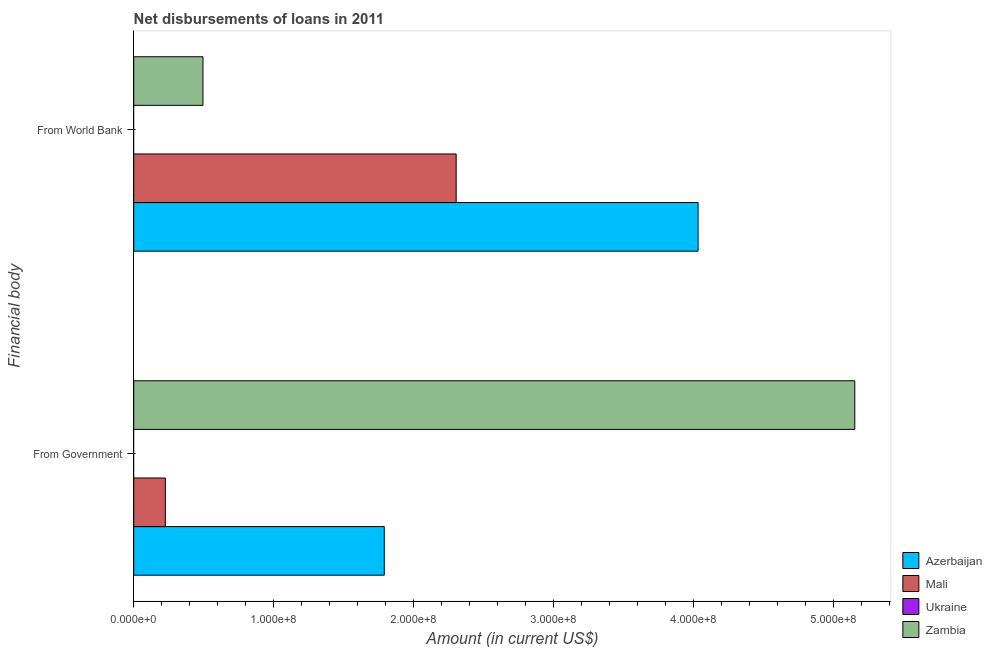How many groups of bars are there?
Your answer should be compact. 2. What is the label of the 1st group of bars from the top?
Your answer should be very brief. From World Bank. What is the net disbursements of loan from government in Zambia?
Ensure brevity in your answer.  5.15e+08. Across all countries, what is the maximum net disbursements of loan from government?
Your response must be concise. 5.15e+08. In which country was the net disbursements of loan from government maximum?
Offer a very short reply. Zambia. What is the total net disbursements of loan from world bank in the graph?
Keep it short and to the point. 6.83e+08. What is the difference between the net disbursements of loan from government in Zambia and that in Azerbaijan?
Offer a terse response. 3.36e+08. What is the difference between the net disbursements of loan from government in Ukraine and the net disbursements of loan from world bank in Azerbaijan?
Your answer should be compact. -4.03e+08. What is the average net disbursements of loan from world bank per country?
Make the answer very short. 1.71e+08. What is the difference between the net disbursements of loan from world bank and net disbursements of loan from government in Zambia?
Offer a very short reply. -4.66e+08. In how many countries, is the net disbursements of loan from world bank greater than 20000000 US$?
Provide a short and direct response. 3. What is the ratio of the net disbursements of loan from world bank in Mali to that in Zambia?
Ensure brevity in your answer.  4.66. Is the net disbursements of loan from world bank in Zambia less than that in Azerbaijan?
Keep it short and to the point. Yes. How many bars are there?
Your answer should be compact. 6. How many countries are there in the graph?
Your response must be concise. 4. What is the difference between two consecutive major ticks on the X-axis?
Offer a very short reply. 1.00e+08. Are the values on the major ticks of X-axis written in scientific E-notation?
Give a very brief answer. Yes. Does the graph contain grids?
Give a very brief answer. No. How are the legend labels stacked?
Give a very brief answer. Vertical. What is the title of the graph?
Your answer should be very brief. Net disbursements of loans in 2011. What is the label or title of the Y-axis?
Your response must be concise. Financial body. What is the Amount (in current US$) in Azerbaijan in From Government?
Offer a terse response. 1.79e+08. What is the Amount (in current US$) of Mali in From Government?
Make the answer very short. 2.26e+07. What is the Amount (in current US$) of Ukraine in From Government?
Provide a short and direct response. 0. What is the Amount (in current US$) of Zambia in From Government?
Provide a short and direct response. 5.15e+08. What is the Amount (in current US$) in Azerbaijan in From World Bank?
Offer a very short reply. 4.03e+08. What is the Amount (in current US$) of Mali in From World Bank?
Make the answer very short. 2.30e+08. What is the Amount (in current US$) of Ukraine in From World Bank?
Give a very brief answer. 0. What is the Amount (in current US$) in Zambia in From World Bank?
Your answer should be very brief. 4.95e+07. Across all Financial body, what is the maximum Amount (in current US$) in Azerbaijan?
Give a very brief answer. 4.03e+08. Across all Financial body, what is the maximum Amount (in current US$) of Mali?
Offer a very short reply. 2.30e+08. Across all Financial body, what is the maximum Amount (in current US$) of Zambia?
Offer a very short reply. 5.15e+08. Across all Financial body, what is the minimum Amount (in current US$) of Azerbaijan?
Give a very brief answer. 1.79e+08. Across all Financial body, what is the minimum Amount (in current US$) in Mali?
Your answer should be very brief. 2.26e+07. Across all Financial body, what is the minimum Amount (in current US$) in Zambia?
Your response must be concise. 4.95e+07. What is the total Amount (in current US$) of Azerbaijan in the graph?
Make the answer very short. 5.82e+08. What is the total Amount (in current US$) in Mali in the graph?
Offer a very short reply. 2.53e+08. What is the total Amount (in current US$) in Zambia in the graph?
Provide a succinct answer. 5.65e+08. What is the difference between the Amount (in current US$) in Azerbaijan in From Government and that in From World Bank?
Provide a short and direct response. -2.24e+08. What is the difference between the Amount (in current US$) of Mali in From Government and that in From World Bank?
Your answer should be very brief. -2.08e+08. What is the difference between the Amount (in current US$) in Zambia in From Government and that in From World Bank?
Offer a terse response. 4.66e+08. What is the difference between the Amount (in current US$) of Azerbaijan in From Government and the Amount (in current US$) of Mali in From World Bank?
Your answer should be compact. -5.14e+07. What is the difference between the Amount (in current US$) in Azerbaijan in From Government and the Amount (in current US$) in Zambia in From World Bank?
Offer a very short reply. 1.30e+08. What is the difference between the Amount (in current US$) of Mali in From Government and the Amount (in current US$) of Zambia in From World Bank?
Offer a terse response. -2.69e+07. What is the average Amount (in current US$) of Azerbaijan per Financial body?
Ensure brevity in your answer.  2.91e+08. What is the average Amount (in current US$) of Mali per Financial body?
Ensure brevity in your answer.  1.26e+08. What is the average Amount (in current US$) in Ukraine per Financial body?
Your answer should be very brief. 0. What is the average Amount (in current US$) of Zambia per Financial body?
Offer a very short reply. 2.82e+08. What is the difference between the Amount (in current US$) in Azerbaijan and Amount (in current US$) in Mali in From Government?
Give a very brief answer. 1.56e+08. What is the difference between the Amount (in current US$) of Azerbaijan and Amount (in current US$) of Zambia in From Government?
Provide a succinct answer. -3.36e+08. What is the difference between the Amount (in current US$) of Mali and Amount (in current US$) of Zambia in From Government?
Your response must be concise. -4.93e+08. What is the difference between the Amount (in current US$) in Azerbaijan and Amount (in current US$) in Mali in From World Bank?
Your answer should be very brief. 1.73e+08. What is the difference between the Amount (in current US$) of Azerbaijan and Amount (in current US$) of Zambia in From World Bank?
Your response must be concise. 3.54e+08. What is the difference between the Amount (in current US$) of Mali and Amount (in current US$) of Zambia in From World Bank?
Provide a short and direct response. 1.81e+08. What is the ratio of the Amount (in current US$) of Azerbaijan in From Government to that in From World Bank?
Make the answer very short. 0.44. What is the ratio of the Amount (in current US$) in Mali in From Government to that in From World Bank?
Provide a short and direct response. 0.1. What is the ratio of the Amount (in current US$) of Zambia in From Government to that in From World Bank?
Provide a short and direct response. 10.42. What is the difference between the highest and the second highest Amount (in current US$) of Azerbaijan?
Keep it short and to the point. 2.24e+08. What is the difference between the highest and the second highest Amount (in current US$) in Mali?
Ensure brevity in your answer.  2.08e+08. What is the difference between the highest and the second highest Amount (in current US$) in Zambia?
Keep it short and to the point. 4.66e+08. What is the difference between the highest and the lowest Amount (in current US$) in Azerbaijan?
Your answer should be compact. 2.24e+08. What is the difference between the highest and the lowest Amount (in current US$) in Mali?
Provide a succinct answer. 2.08e+08. What is the difference between the highest and the lowest Amount (in current US$) in Zambia?
Make the answer very short. 4.66e+08. 